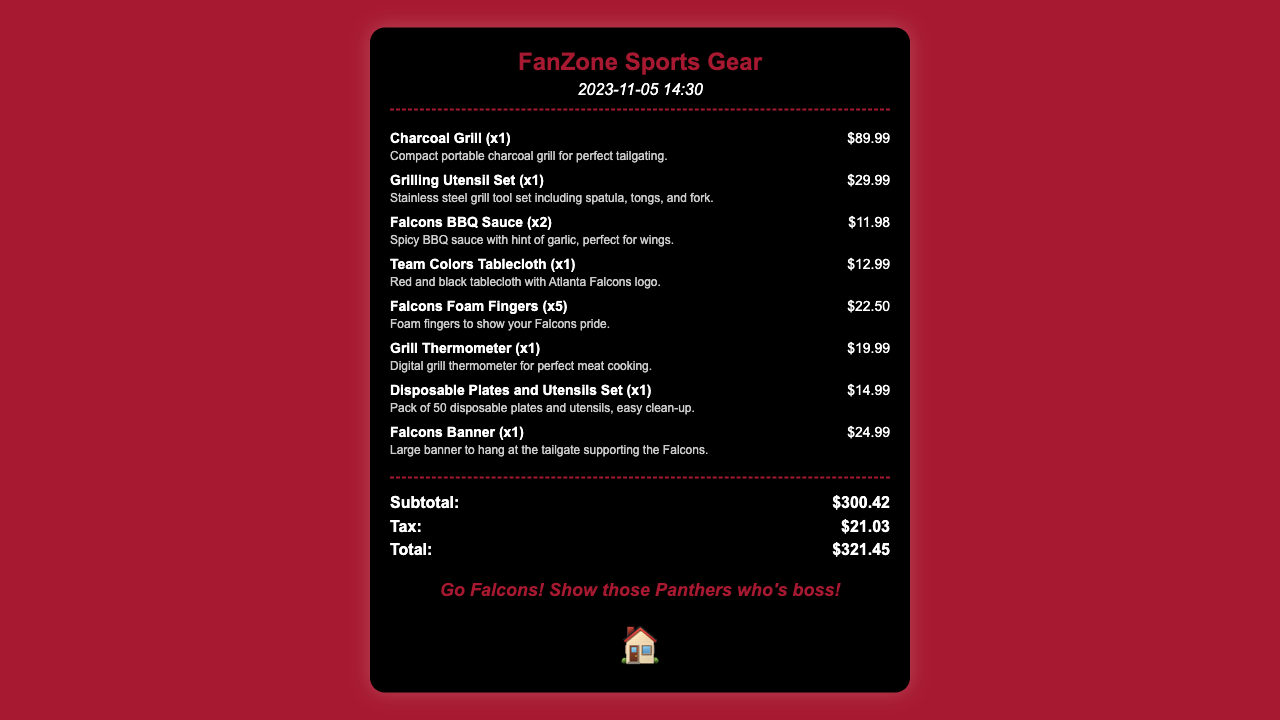What is the date of the receipt? The date of the receipt is listed in the document's header.
Answer: 2023-11-05 What store issued this receipt? The store name is prominently displayed at the top of the receipt.
Answer: FanZone Sports Gear How much did the Charcoal Grill cost? The price for the Charcoal Grill is stated next to its name in the items list.
Answer: $89.99 What is the total amount spent? The total amount is calculated from the subtotal and tax at the bottom of the receipt.
Answer: $321.45 How many Falcons Foam Fingers were purchased? The quantity of Falcons Foam Fingers is mentioned alongside the product in the items list.
Answer: 5 What type of grill is listed on the receipt? The item description provides the type of grill in the items section.
Answer: Charcoal Grill What is the total cost of the Falcons BBQ Sauce? The price of two bottles of BBQ sauce is provided in the items list.
Answer: $11.98 What is the message at the bottom of the receipt? The message is located at the bottom of the receipt encouraging team spirit.
Answer: Go Falcons! Show those Panthers who's boss! 